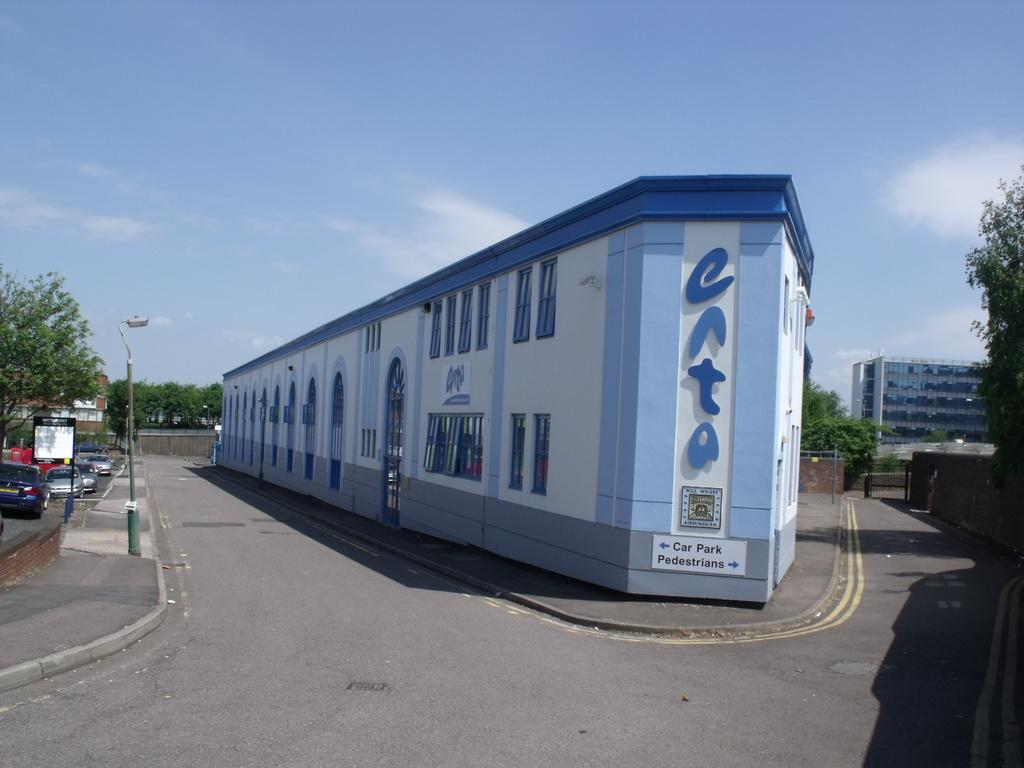<image>
Relay a brief, clear account of the picture shown. a blue building has signs for parking and pedestrians on seperate sides 